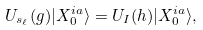<formula> <loc_0><loc_0><loc_500><loc_500>U _ { s _ { \ell } } ( g ) | X _ { 0 } ^ { i a } \rangle = U _ { I } ( h ) | X _ { 0 } ^ { i a } \rangle ,</formula> 